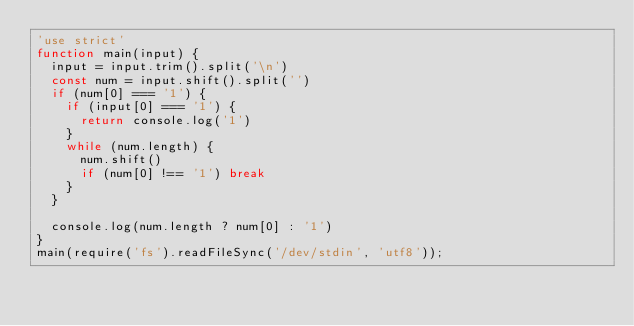<code> <loc_0><loc_0><loc_500><loc_500><_JavaScript_>'use strict'
function main(input) {
  input = input.trim().split('\n')
  const num = input.shift().split('')
  if (num[0] === '1') {
    if (input[0] === '1') {
      return console.log('1')
    }
    while (num.length) {
      num.shift()
      if (num[0] !== '1') break
    }
  }

  console.log(num.length ? num[0] : '1')
}
main(require('fs').readFileSync('/dev/stdin', 'utf8'));
</code> 